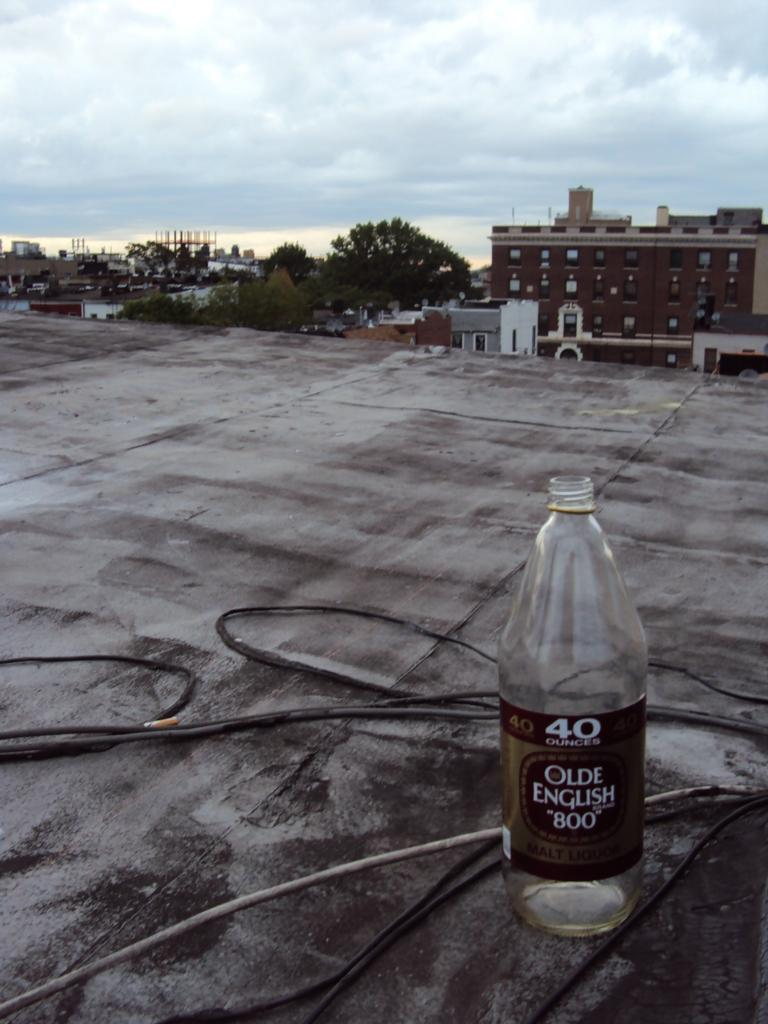Provide a one-sentence caption for the provided image. A bottle of Olde English malt liquor is sitting on a desolate roof surrounded by wires. 